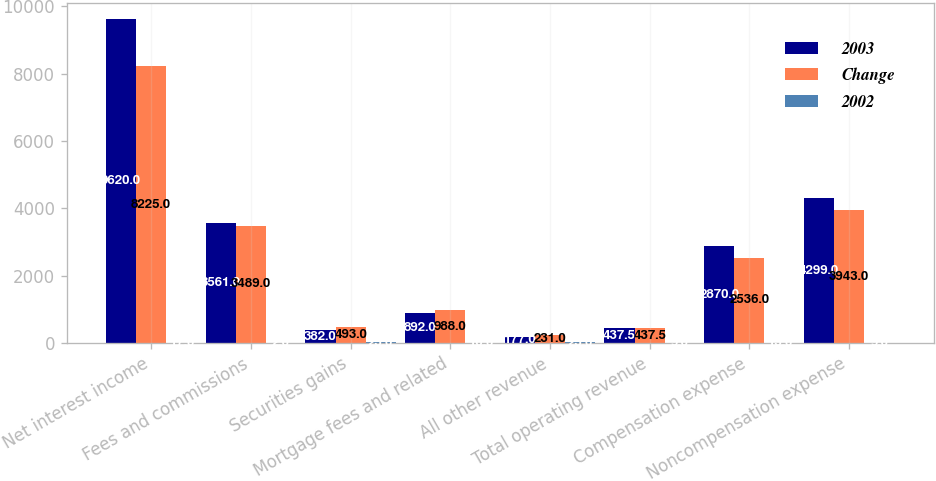Convert chart to OTSL. <chart><loc_0><loc_0><loc_500><loc_500><stacked_bar_chart><ecel><fcel>Net interest income<fcel>Fees and commissions<fcel>Securities gains<fcel>Mortgage fees and related<fcel>All other revenue<fcel>Total operating revenue<fcel>Compensation expense<fcel>Noncompensation expense<nl><fcel>2003<fcel>9620<fcel>3561<fcel>382<fcel>892<fcel>177<fcel>437.5<fcel>2870<fcel>4299<nl><fcel>Change<fcel>8225<fcel>3489<fcel>493<fcel>988<fcel>231<fcel>437.5<fcel>2536<fcel>3943<nl><fcel>2002<fcel>17<fcel>2<fcel>23<fcel>10<fcel>23<fcel>9<fcel>13<fcel>9<nl></chart> 